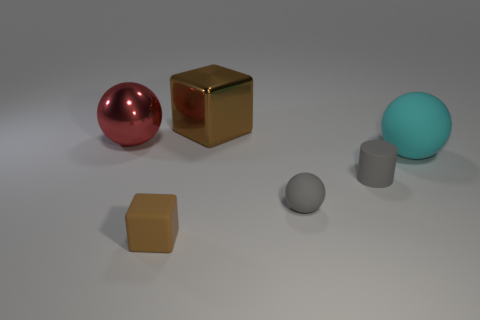There is a big thing that is the same material as the red sphere; what color is it?
Offer a terse response. Brown. What color is the block on the left side of the brown shiny cube?
Provide a short and direct response. Brown. What number of other rubber balls are the same color as the small ball?
Ensure brevity in your answer.  0. Are there fewer red metallic spheres that are behind the big block than gray matte cylinders behind the small gray rubber cylinder?
Give a very brief answer. No. What number of big cyan rubber things are behind the large red shiny ball?
Make the answer very short. 0. Are there any small gray cylinders made of the same material as the red object?
Provide a short and direct response. No. Are there more cyan objects on the left side of the small gray rubber sphere than small gray rubber cylinders that are behind the large matte thing?
Make the answer very short. No. The cyan matte thing has what size?
Your response must be concise. Large. The brown object that is in front of the cyan object has what shape?
Your answer should be very brief. Cube. Is the big red metallic object the same shape as the brown rubber thing?
Offer a terse response. No. 